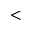<formula> <loc_0><loc_0><loc_500><loc_500><</formula> 